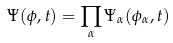<formula> <loc_0><loc_0><loc_500><loc_500>\Psi ( \phi , t ) = \prod _ { \alpha } \Psi _ { \alpha } ( \phi _ { \alpha } , t )</formula> 